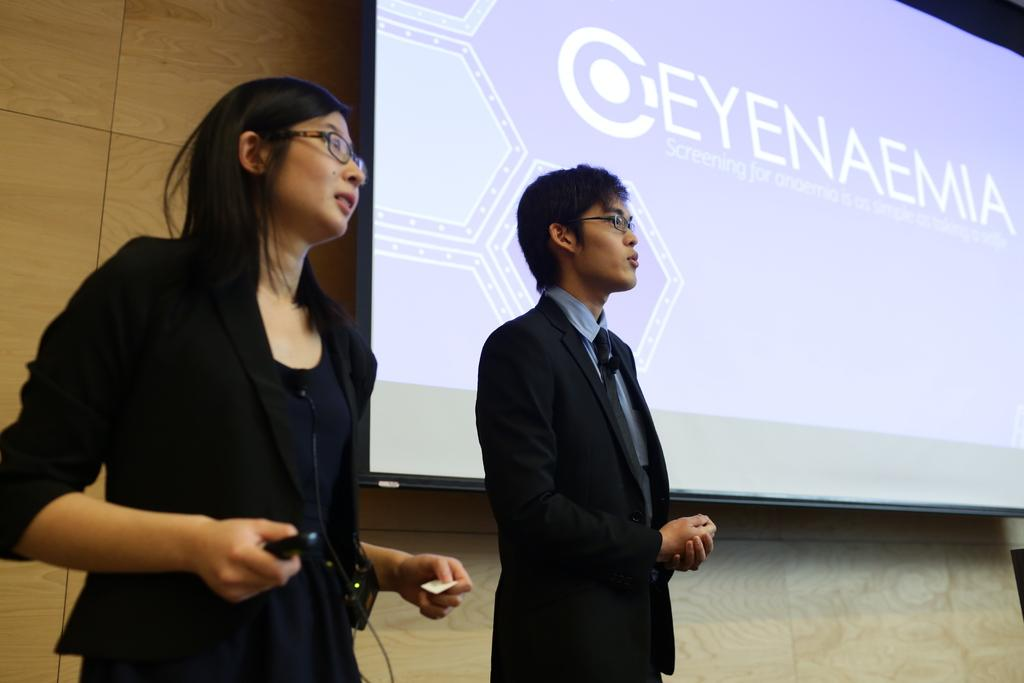How many people are present in the image? There are two persons standing in the image. Can you describe the background of the image? There is a screen attached to the wall in the background of the image. What type of fish can be seen swimming on the screen in the image? There is no fish present in the image; the screen is not displaying any aquatic life. 